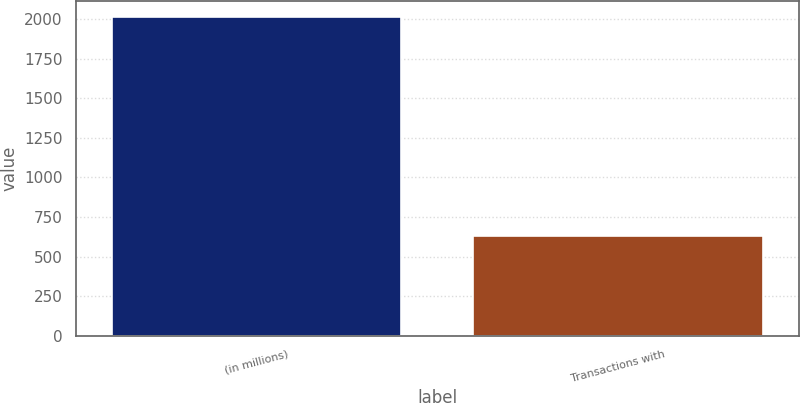Convert chart. <chart><loc_0><loc_0><loc_500><loc_500><bar_chart><fcel>(in millions)<fcel>Transactions with<nl><fcel>2013<fcel>632<nl></chart> 